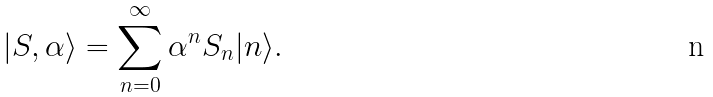Convert formula to latex. <formula><loc_0><loc_0><loc_500><loc_500>| S , \alpha \rangle = \sum _ { n = 0 } ^ { \infty } \alpha ^ { n } S _ { n } | n \rangle .</formula> 